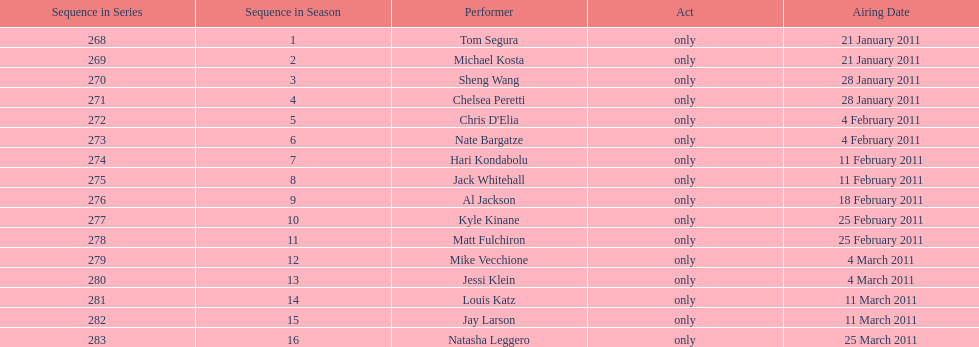In february, what was the overall number of air dates? 7. 